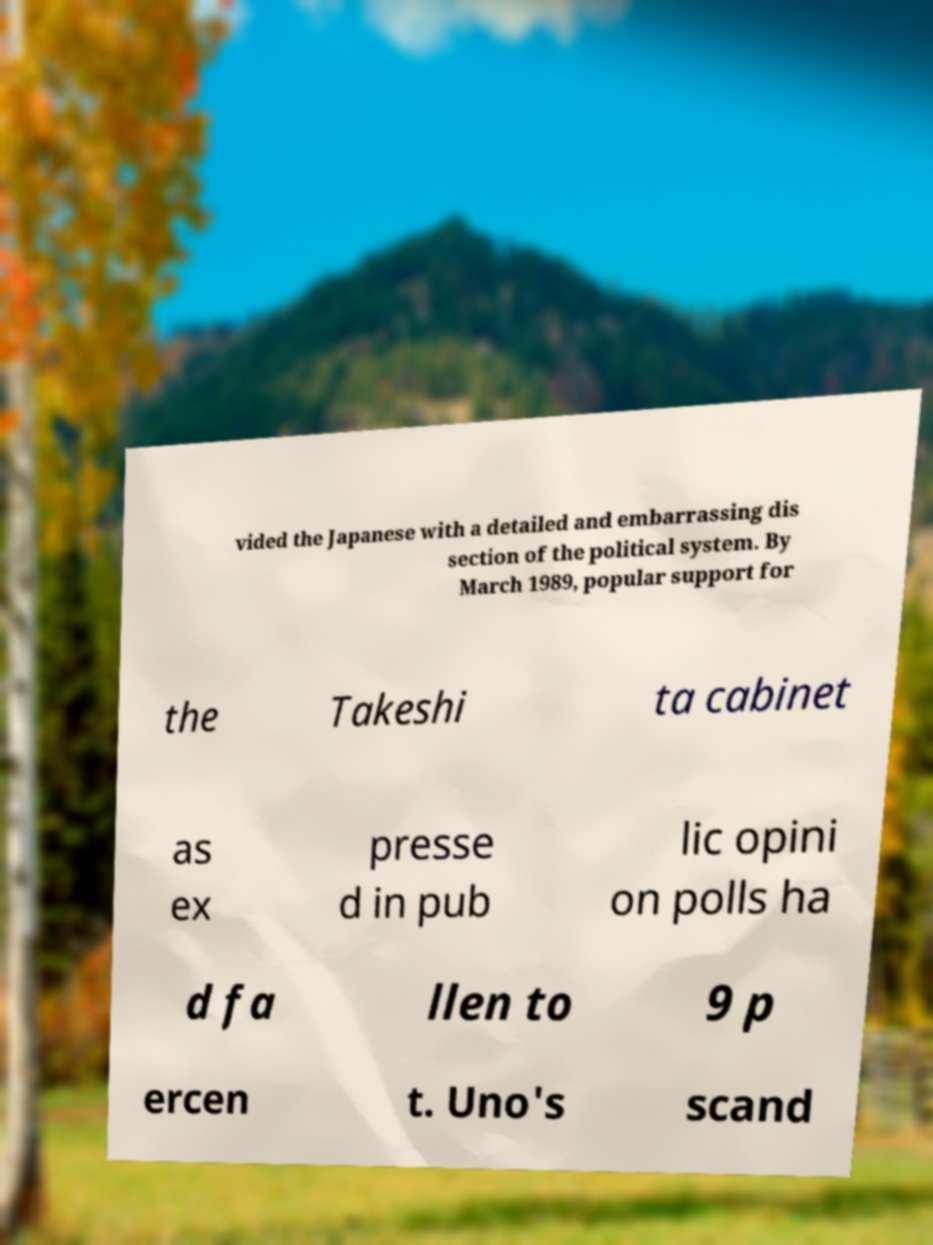For documentation purposes, I need the text within this image transcribed. Could you provide that? vided the Japanese with a detailed and embarrassing dis section of the political system. By March 1989, popular support for the Takeshi ta cabinet as ex presse d in pub lic opini on polls ha d fa llen to 9 p ercen t. Uno's scand 